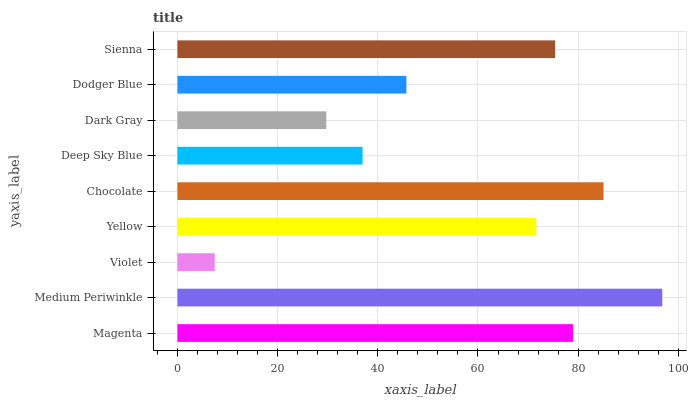Is Violet the minimum?
Answer yes or no. Yes. Is Medium Periwinkle the maximum?
Answer yes or no. Yes. Is Medium Periwinkle the minimum?
Answer yes or no. No. Is Violet the maximum?
Answer yes or no. No. Is Medium Periwinkle greater than Violet?
Answer yes or no. Yes. Is Violet less than Medium Periwinkle?
Answer yes or no. Yes. Is Violet greater than Medium Periwinkle?
Answer yes or no. No. Is Medium Periwinkle less than Violet?
Answer yes or no. No. Is Yellow the high median?
Answer yes or no. Yes. Is Yellow the low median?
Answer yes or no. Yes. Is Deep Sky Blue the high median?
Answer yes or no. No. Is Violet the low median?
Answer yes or no. No. 